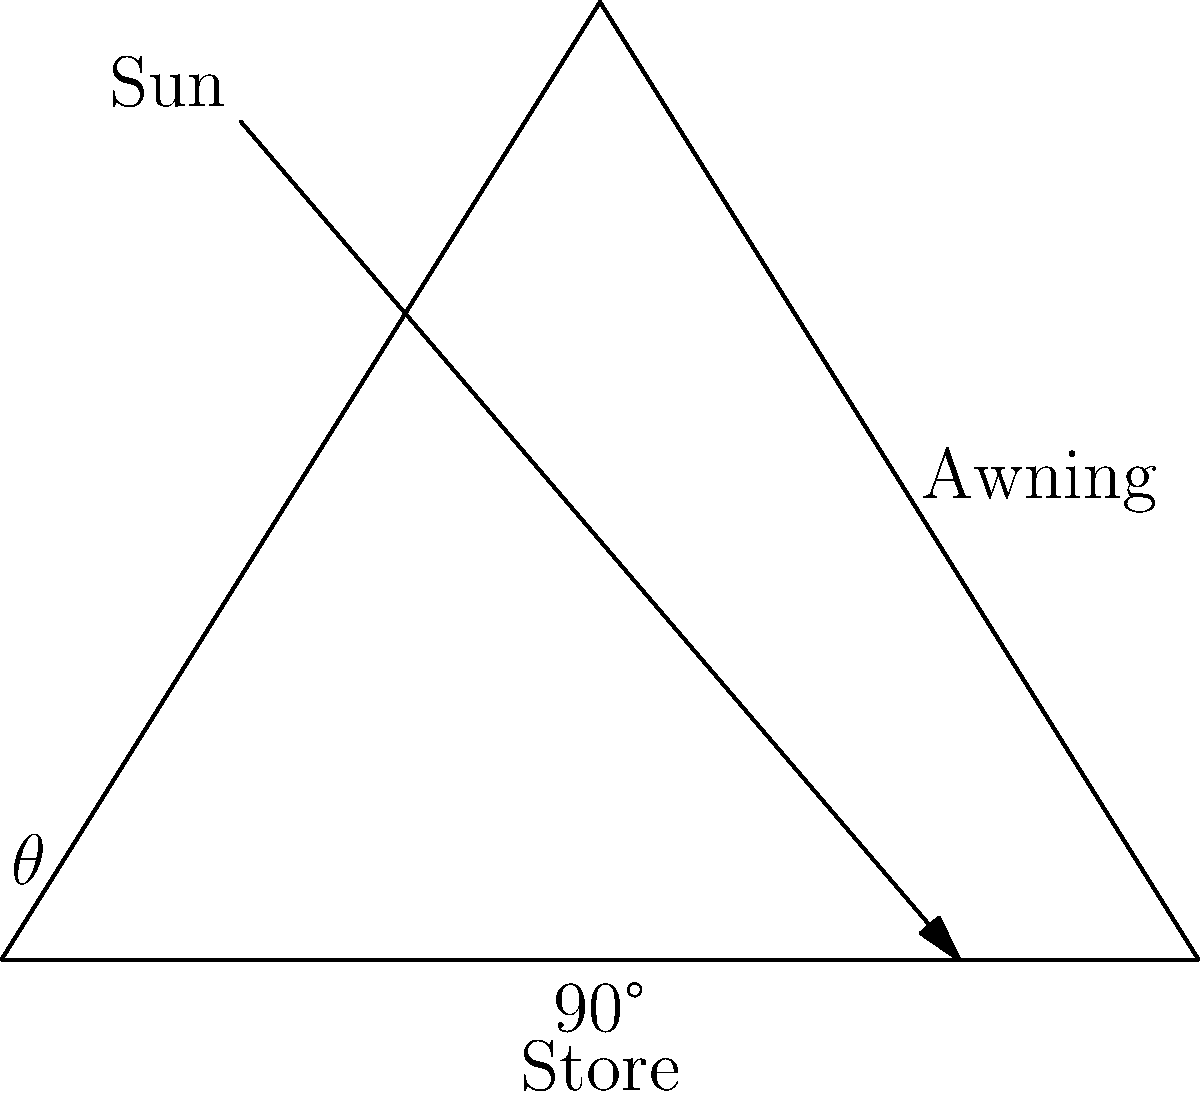You want to install an awning on your store to provide maximum shade during the hottest part of the day. If the sun is at an elevation angle of 60° above the horizon, what angle $\theta$ should the awning make with the storefront to be perpendicular to the sun's rays? To find the optimal angle for the awning, we need to consider that it should be perpendicular to the sun's rays for maximum shade. Let's approach this step-by-step:

1) The sun's elevation angle is given as 60° above the horizon.

2) In a right triangle formed by the sun's rays and the horizon, this 60° angle would be complementary to the angle between the sun's rays and a vertical line.

3) The complementary angle is calculated as: 90° - 60° = 30°

4) For the awning to be perpendicular to the sun's rays, it must form this 30° angle with the vertical.

5) The angle we're looking for, $\theta$, is between the awning and the horizontal storefront.

6) Since the awning forms a 30° angle with the vertical, and the vertical forms a 90° angle with the storefront, we can find $\theta$ by subtracting:

   $\theta = 90° - 30° = 60°$

Therefore, the awning should be installed at a 60° angle with respect to the storefront to be perpendicular to the sun's rays and provide maximum shade.
Answer: 60° 